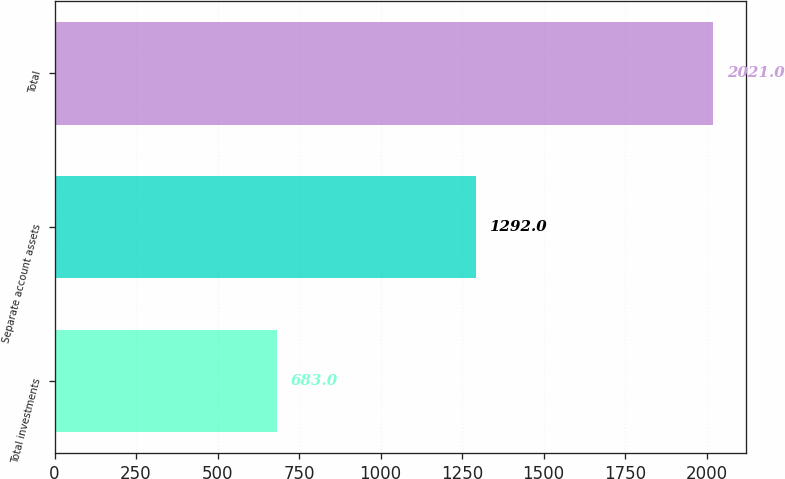Convert chart. <chart><loc_0><loc_0><loc_500><loc_500><bar_chart><fcel>Total investments<fcel>Separate account assets<fcel>Total<nl><fcel>683<fcel>1292<fcel>2021<nl></chart> 